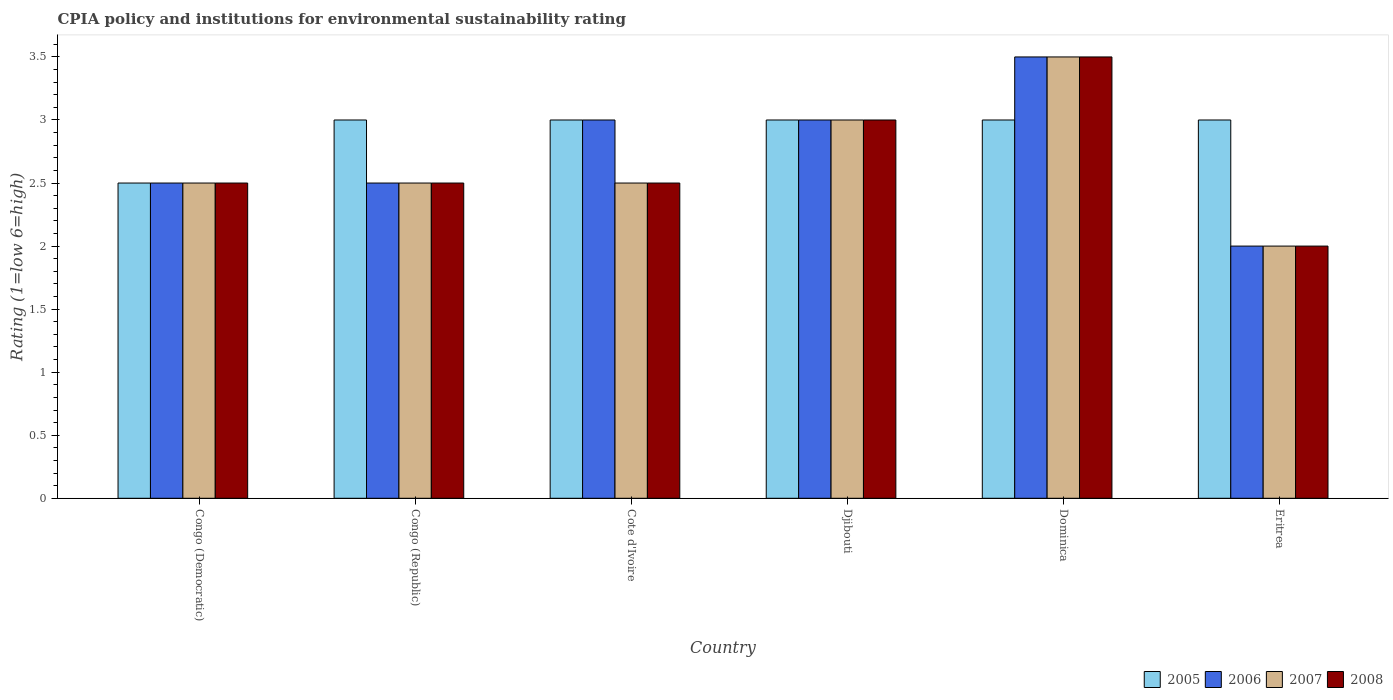Are the number of bars per tick equal to the number of legend labels?
Keep it short and to the point. Yes. How many bars are there on the 1st tick from the left?
Your answer should be very brief. 4. How many bars are there on the 5th tick from the right?
Your answer should be very brief. 4. What is the label of the 2nd group of bars from the left?
Make the answer very short. Congo (Republic). What is the CPIA rating in 2005 in Congo (Republic)?
Your answer should be compact. 3. Across all countries, what is the maximum CPIA rating in 2006?
Provide a short and direct response. 3.5. Across all countries, what is the minimum CPIA rating in 2005?
Your response must be concise. 2.5. In which country was the CPIA rating in 2008 maximum?
Your response must be concise. Dominica. In which country was the CPIA rating in 2006 minimum?
Your response must be concise. Eritrea. What is the total CPIA rating in 2005 in the graph?
Give a very brief answer. 17.5. What is the difference between the CPIA rating in 2007 in Congo (Democratic) and that in Djibouti?
Offer a very short reply. -0.5. What is the difference between the CPIA rating in 2006 in Djibouti and the CPIA rating in 2007 in Cote d'Ivoire?
Make the answer very short. 0.5. What is the average CPIA rating in 2007 per country?
Offer a terse response. 2.67. In how many countries, is the CPIA rating in 2007 greater than 0.9?
Give a very brief answer. 6. What is the ratio of the CPIA rating in 2005 in Djibouti to that in Eritrea?
Offer a terse response. 1. Is the CPIA rating in 2007 in Cote d'Ivoire less than that in Djibouti?
Your response must be concise. Yes. What is the difference between the highest and the second highest CPIA rating in 2008?
Give a very brief answer. 0.5. What is the difference between the highest and the lowest CPIA rating in 2007?
Your response must be concise. 1.5. In how many countries, is the CPIA rating in 2005 greater than the average CPIA rating in 2005 taken over all countries?
Your response must be concise. 5. What does the 4th bar from the left in Cote d'Ivoire represents?
Offer a very short reply. 2008. What does the 4th bar from the right in Congo (Democratic) represents?
Give a very brief answer. 2005. Is it the case that in every country, the sum of the CPIA rating in 2007 and CPIA rating in 2008 is greater than the CPIA rating in 2005?
Ensure brevity in your answer.  Yes. What is the difference between two consecutive major ticks on the Y-axis?
Provide a short and direct response. 0.5. Does the graph contain any zero values?
Provide a short and direct response. No. Does the graph contain grids?
Make the answer very short. No. Where does the legend appear in the graph?
Your answer should be very brief. Bottom right. How many legend labels are there?
Keep it short and to the point. 4. How are the legend labels stacked?
Offer a terse response. Horizontal. What is the title of the graph?
Give a very brief answer. CPIA policy and institutions for environmental sustainability rating. What is the label or title of the X-axis?
Keep it short and to the point. Country. What is the Rating (1=low 6=high) of 2008 in Congo (Democratic)?
Your answer should be compact. 2.5. What is the Rating (1=low 6=high) of 2006 in Congo (Republic)?
Keep it short and to the point. 2.5. What is the Rating (1=low 6=high) in 2007 in Congo (Republic)?
Provide a succinct answer. 2.5. What is the Rating (1=low 6=high) of 2008 in Congo (Republic)?
Offer a very short reply. 2.5. What is the Rating (1=low 6=high) of 2005 in Cote d'Ivoire?
Keep it short and to the point. 3. What is the Rating (1=low 6=high) in 2006 in Cote d'Ivoire?
Keep it short and to the point. 3. What is the Rating (1=low 6=high) of 2007 in Cote d'Ivoire?
Provide a short and direct response. 2.5. What is the Rating (1=low 6=high) of 2006 in Djibouti?
Provide a succinct answer. 3. What is the Rating (1=low 6=high) in 2007 in Djibouti?
Offer a very short reply. 3. What is the Rating (1=low 6=high) in 2008 in Djibouti?
Ensure brevity in your answer.  3. What is the Rating (1=low 6=high) in 2005 in Dominica?
Your response must be concise. 3. What is the Rating (1=low 6=high) of 2007 in Dominica?
Provide a succinct answer. 3.5. What is the Rating (1=low 6=high) of 2007 in Eritrea?
Your answer should be compact. 2. Across all countries, what is the maximum Rating (1=low 6=high) in 2006?
Make the answer very short. 3.5. Across all countries, what is the maximum Rating (1=low 6=high) in 2007?
Keep it short and to the point. 3.5. Across all countries, what is the minimum Rating (1=low 6=high) in 2005?
Provide a succinct answer. 2.5. Across all countries, what is the minimum Rating (1=low 6=high) in 2006?
Offer a very short reply. 2. Across all countries, what is the minimum Rating (1=low 6=high) of 2007?
Your response must be concise. 2. What is the total Rating (1=low 6=high) of 2006 in the graph?
Your response must be concise. 16.5. What is the total Rating (1=low 6=high) of 2007 in the graph?
Offer a terse response. 16. What is the difference between the Rating (1=low 6=high) in 2005 in Congo (Democratic) and that in Congo (Republic)?
Your answer should be very brief. -0.5. What is the difference between the Rating (1=low 6=high) of 2007 in Congo (Democratic) and that in Congo (Republic)?
Provide a succinct answer. 0. What is the difference between the Rating (1=low 6=high) of 2006 in Congo (Democratic) and that in Cote d'Ivoire?
Make the answer very short. -0.5. What is the difference between the Rating (1=low 6=high) of 2007 in Congo (Democratic) and that in Cote d'Ivoire?
Give a very brief answer. 0. What is the difference between the Rating (1=low 6=high) of 2008 in Congo (Democratic) and that in Cote d'Ivoire?
Offer a very short reply. 0. What is the difference between the Rating (1=low 6=high) of 2005 in Congo (Democratic) and that in Djibouti?
Your response must be concise. -0.5. What is the difference between the Rating (1=low 6=high) in 2008 in Congo (Democratic) and that in Djibouti?
Your answer should be very brief. -0.5. What is the difference between the Rating (1=low 6=high) in 2007 in Congo (Democratic) and that in Dominica?
Provide a succinct answer. -1. What is the difference between the Rating (1=low 6=high) in 2008 in Congo (Democratic) and that in Dominica?
Your answer should be compact. -1. What is the difference between the Rating (1=low 6=high) in 2005 in Congo (Republic) and that in Djibouti?
Your answer should be compact. 0. What is the difference between the Rating (1=low 6=high) in 2007 in Congo (Republic) and that in Djibouti?
Your answer should be compact. -0.5. What is the difference between the Rating (1=low 6=high) in 2005 in Congo (Republic) and that in Dominica?
Keep it short and to the point. 0. What is the difference between the Rating (1=low 6=high) of 2006 in Congo (Republic) and that in Dominica?
Offer a terse response. -1. What is the difference between the Rating (1=low 6=high) in 2007 in Congo (Republic) and that in Dominica?
Offer a terse response. -1. What is the difference between the Rating (1=low 6=high) in 2008 in Congo (Republic) and that in Dominica?
Offer a very short reply. -1. What is the difference between the Rating (1=low 6=high) of 2006 in Congo (Republic) and that in Eritrea?
Provide a succinct answer. 0.5. What is the difference between the Rating (1=low 6=high) in 2008 in Congo (Republic) and that in Eritrea?
Offer a terse response. 0.5. What is the difference between the Rating (1=low 6=high) of 2006 in Cote d'Ivoire and that in Djibouti?
Give a very brief answer. 0. What is the difference between the Rating (1=low 6=high) in 2007 in Cote d'Ivoire and that in Djibouti?
Your answer should be compact. -0.5. What is the difference between the Rating (1=low 6=high) in 2006 in Cote d'Ivoire and that in Dominica?
Your answer should be compact. -0.5. What is the difference between the Rating (1=low 6=high) in 2008 in Cote d'Ivoire and that in Dominica?
Provide a short and direct response. -1. What is the difference between the Rating (1=low 6=high) of 2005 in Cote d'Ivoire and that in Eritrea?
Keep it short and to the point. 0. What is the difference between the Rating (1=low 6=high) of 2007 in Cote d'Ivoire and that in Eritrea?
Ensure brevity in your answer.  0.5. What is the difference between the Rating (1=low 6=high) in 2005 in Djibouti and that in Dominica?
Offer a terse response. 0. What is the difference between the Rating (1=low 6=high) of 2006 in Djibouti and that in Dominica?
Your answer should be compact. -0.5. What is the difference between the Rating (1=low 6=high) in 2007 in Djibouti and that in Dominica?
Keep it short and to the point. -0.5. What is the difference between the Rating (1=low 6=high) in 2005 in Djibouti and that in Eritrea?
Your response must be concise. 0. What is the difference between the Rating (1=low 6=high) of 2006 in Djibouti and that in Eritrea?
Provide a succinct answer. 1. What is the difference between the Rating (1=low 6=high) in 2007 in Djibouti and that in Eritrea?
Your answer should be compact. 1. What is the difference between the Rating (1=low 6=high) of 2008 in Djibouti and that in Eritrea?
Your answer should be compact. 1. What is the difference between the Rating (1=low 6=high) in 2005 in Dominica and that in Eritrea?
Offer a terse response. 0. What is the difference between the Rating (1=low 6=high) of 2007 in Dominica and that in Eritrea?
Your answer should be very brief. 1.5. What is the difference between the Rating (1=low 6=high) in 2005 in Congo (Democratic) and the Rating (1=low 6=high) in 2007 in Congo (Republic)?
Give a very brief answer. 0. What is the difference between the Rating (1=low 6=high) in 2006 in Congo (Democratic) and the Rating (1=low 6=high) in 2007 in Congo (Republic)?
Offer a terse response. 0. What is the difference between the Rating (1=low 6=high) in 2006 in Congo (Democratic) and the Rating (1=low 6=high) in 2008 in Congo (Republic)?
Ensure brevity in your answer.  0. What is the difference between the Rating (1=low 6=high) in 2005 in Congo (Democratic) and the Rating (1=low 6=high) in 2006 in Cote d'Ivoire?
Your response must be concise. -0.5. What is the difference between the Rating (1=low 6=high) in 2005 in Congo (Democratic) and the Rating (1=low 6=high) in 2008 in Cote d'Ivoire?
Your response must be concise. 0. What is the difference between the Rating (1=low 6=high) in 2006 in Congo (Democratic) and the Rating (1=low 6=high) in 2007 in Cote d'Ivoire?
Keep it short and to the point. 0. What is the difference between the Rating (1=low 6=high) of 2005 in Congo (Democratic) and the Rating (1=low 6=high) of 2006 in Djibouti?
Provide a short and direct response. -0.5. What is the difference between the Rating (1=low 6=high) in 2005 in Congo (Democratic) and the Rating (1=low 6=high) in 2007 in Djibouti?
Ensure brevity in your answer.  -0.5. What is the difference between the Rating (1=low 6=high) of 2006 in Congo (Democratic) and the Rating (1=low 6=high) of 2007 in Djibouti?
Provide a succinct answer. -0.5. What is the difference between the Rating (1=low 6=high) in 2005 in Congo (Democratic) and the Rating (1=low 6=high) in 2008 in Dominica?
Provide a succinct answer. -1. What is the difference between the Rating (1=low 6=high) of 2006 in Congo (Democratic) and the Rating (1=low 6=high) of 2007 in Dominica?
Offer a terse response. -1. What is the difference between the Rating (1=low 6=high) in 2007 in Congo (Democratic) and the Rating (1=low 6=high) in 2008 in Dominica?
Give a very brief answer. -1. What is the difference between the Rating (1=low 6=high) in 2005 in Congo (Democratic) and the Rating (1=low 6=high) in 2006 in Eritrea?
Provide a succinct answer. 0.5. What is the difference between the Rating (1=low 6=high) in 2006 in Congo (Democratic) and the Rating (1=low 6=high) in 2007 in Eritrea?
Provide a short and direct response. 0.5. What is the difference between the Rating (1=low 6=high) in 2006 in Congo (Democratic) and the Rating (1=low 6=high) in 2008 in Eritrea?
Give a very brief answer. 0.5. What is the difference between the Rating (1=low 6=high) of 2007 in Congo (Democratic) and the Rating (1=low 6=high) of 2008 in Eritrea?
Ensure brevity in your answer.  0.5. What is the difference between the Rating (1=low 6=high) of 2005 in Congo (Republic) and the Rating (1=low 6=high) of 2006 in Cote d'Ivoire?
Your answer should be very brief. 0. What is the difference between the Rating (1=low 6=high) of 2005 in Congo (Republic) and the Rating (1=low 6=high) of 2007 in Cote d'Ivoire?
Your answer should be compact. 0.5. What is the difference between the Rating (1=low 6=high) of 2005 in Congo (Republic) and the Rating (1=low 6=high) of 2008 in Cote d'Ivoire?
Offer a very short reply. 0.5. What is the difference between the Rating (1=low 6=high) in 2006 in Congo (Republic) and the Rating (1=low 6=high) in 2007 in Cote d'Ivoire?
Your answer should be compact. 0. What is the difference between the Rating (1=low 6=high) in 2006 in Congo (Republic) and the Rating (1=low 6=high) in 2008 in Cote d'Ivoire?
Your answer should be compact. 0. What is the difference between the Rating (1=low 6=high) in 2007 in Congo (Republic) and the Rating (1=low 6=high) in 2008 in Cote d'Ivoire?
Keep it short and to the point. 0. What is the difference between the Rating (1=low 6=high) of 2005 in Congo (Republic) and the Rating (1=low 6=high) of 2006 in Djibouti?
Keep it short and to the point. 0. What is the difference between the Rating (1=low 6=high) in 2005 in Congo (Republic) and the Rating (1=low 6=high) in 2008 in Djibouti?
Offer a terse response. 0. What is the difference between the Rating (1=low 6=high) of 2006 in Congo (Republic) and the Rating (1=low 6=high) of 2008 in Djibouti?
Offer a terse response. -0.5. What is the difference between the Rating (1=low 6=high) in 2005 in Congo (Republic) and the Rating (1=low 6=high) in 2006 in Dominica?
Offer a terse response. -0.5. What is the difference between the Rating (1=low 6=high) of 2005 in Congo (Republic) and the Rating (1=low 6=high) of 2007 in Dominica?
Ensure brevity in your answer.  -0.5. What is the difference between the Rating (1=low 6=high) of 2005 in Congo (Republic) and the Rating (1=low 6=high) of 2008 in Dominica?
Offer a terse response. -0.5. What is the difference between the Rating (1=low 6=high) in 2006 in Congo (Republic) and the Rating (1=low 6=high) in 2007 in Dominica?
Offer a terse response. -1. What is the difference between the Rating (1=low 6=high) of 2005 in Congo (Republic) and the Rating (1=low 6=high) of 2006 in Eritrea?
Offer a terse response. 1. What is the difference between the Rating (1=low 6=high) of 2005 in Congo (Republic) and the Rating (1=low 6=high) of 2007 in Eritrea?
Ensure brevity in your answer.  1. What is the difference between the Rating (1=low 6=high) in 2005 in Congo (Republic) and the Rating (1=low 6=high) in 2008 in Eritrea?
Provide a succinct answer. 1. What is the difference between the Rating (1=low 6=high) in 2006 in Congo (Republic) and the Rating (1=low 6=high) in 2007 in Eritrea?
Provide a succinct answer. 0.5. What is the difference between the Rating (1=low 6=high) in 2006 in Congo (Republic) and the Rating (1=low 6=high) in 2008 in Eritrea?
Make the answer very short. 0.5. What is the difference between the Rating (1=low 6=high) in 2005 in Cote d'Ivoire and the Rating (1=low 6=high) in 2006 in Djibouti?
Make the answer very short. 0. What is the difference between the Rating (1=low 6=high) of 2005 in Cote d'Ivoire and the Rating (1=low 6=high) of 2008 in Djibouti?
Your response must be concise. 0. What is the difference between the Rating (1=low 6=high) of 2006 in Cote d'Ivoire and the Rating (1=low 6=high) of 2007 in Djibouti?
Offer a very short reply. 0. What is the difference between the Rating (1=low 6=high) of 2006 in Cote d'Ivoire and the Rating (1=low 6=high) of 2008 in Djibouti?
Your answer should be very brief. 0. What is the difference between the Rating (1=low 6=high) of 2005 in Cote d'Ivoire and the Rating (1=low 6=high) of 2006 in Dominica?
Your answer should be compact. -0.5. What is the difference between the Rating (1=low 6=high) in 2005 in Cote d'Ivoire and the Rating (1=low 6=high) in 2008 in Dominica?
Ensure brevity in your answer.  -0.5. What is the difference between the Rating (1=low 6=high) in 2005 in Cote d'Ivoire and the Rating (1=low 6=high) in 2006 in Eritrea?
Offer a terse response. 1. What is the difference between the Rating (1=low 6=high) of 2006 in Cote d'Ivoire and the Rating (1=low 6=high) of 2008 in Eritrea?
Offer a terse response. 1. What is the difference between the Rating (1=low 6=high) in 2005 in Djibouti and the Rating (1=low 6=high) in 2007 in Eritrea?
Offer a terse response. 1. What is the difference between the Rating (1=low 6=high) in 2006 in Djibouti and the Rating (1=low 6=high) in 2007 in Eritrea?
Provide a succinct answer. 1. What is the difference between the Rating (1=low 6=high) of 2005 in Dominica and the Rating (1=low 6=high) of 2007 in Eritrea?
Offer a terse response. 1. What is the difference between the Rating (1=low 6=high) of 2005 in Dominica and the Rating (1=low 6=high) of 2008 in Eritrea?
Your response must be concise. 1. What is the difference between the Rating (1=low 6=high) of 2006 in Dominica and the Rating (1=low 6=high) of 2007 in Eritrea?
Your answer should be compact. 1.5. What is the difference between the Rating (1=low 6=high) in 2007 in Dominica and the Rating (1=low 6=high) in 2008 in Eritrea?
Give a very brief answer. 1.5. What is the average Rating (1=low 6=high) of 2005 per country?
Give a very brief answer. 2.92. What is the average Rating (1=low 6=high) in 2006 per country?
Make the answer very short. 2.75. What is the average Rating (1=low 6=high) of 2007 per country?
Your response must be concise. 2.67. What is the average Rating (1=low 6=high) of 2008 per country?
Give a very brief answer. 2.67. What is the difference between the Rating (1=low 6=high) in 2005 and Rating (1=low 6=high) in 2006 in Congo (Democratic)?
Give a very brief answer. 0. What is the difference between the Rating (1=low 6=high) in 2005 and Rating (1=low 6=high) in 2007 in Congo (Democratic)?
Offer a very short reply. 0. What is the difference between the Rating (1=low 6=high) of 2005 and Rating (1=low 6=high) of 2008 in Congo (Democratic)?
Your response must be concise. 0. What is the difference between the Rating (1=low 6=high) in 2006 and Rating (1=low 6=high) in 2007 in Congo (Democratic)?
Offer a terse response. 0. What is the difference between the Rating (1=low 6=high) in 2007 and Rating (1=low 6=high) in 2008 in Congo (Democratic)?
Make the answer very short. 0. What is the difference between the Rating (1=low 6=high) of 2005 and Rating (1=low 6=high) of 2008 in Congo (Republic)?
Give a very brief answer. 0.5. What is the difference between the Rating (1=low 6=high) in 2006 and Rating (1=low 6=high) in 2007 in Congo (Republic)?
Keep it short and to the point. 0. What is the difference between the Rating (1=low 6=high) of 2007 and Rating (1=low 6=high) of 2008 in Congo (Republic)?
Give a very brief answer. 0. What is the difference between the Rating (1=low 6=high) of 2005 and Rating (1=low 6=high) of 2008 in Cote d'Ivoire?
Keep it short and to the point. 0.5. What is the difference between the Rating (1=low 6=high) of 2006 and Rating (1=low 6=high) of 2008 in Cote d'Ivoire?
Your answer should be very brief. 0.5. What is the difference between the Rating (1=low 6=high) of 2005 and Rating (1=low 6=high) of 2006 in Djibouti?
Provide a short and direct response. 0. What is the difference between the Rating (1=low 6=high) of 2005 and Rating (1=low 6=high) of 2007 in Djibouti?
Give a very brief answer. 0. What is the difference between the Rating (1=low 6=high) of 2006 and Rating (1=low 6=high) of 2007 in Djibouti?
Your answer should be very brief. 0. What is the difference between the Rating (1=low 6=high) of 2006 and Rating (1=low 6=high) of 2008 in Djibouti?
Ensure brevity in your answer.  0. What is the difference between the Rating (1=low 6=high) of 2005 and Rating (1=low 6=high) of 2006 in Dominica?
Keep it short and to the point. -0.5. What is the difference between the Rating (1=low 6=high) in 2005 and Rating (1=low 6=high) in 2008 in Dominica?
Provide a short and direct response. -0.5. What is the difference between the Rating (1=low 6=high) of 2006 and Rating (1=low 6=high) of 2008 in Dominica?
Provide a succinct answer. 0. What is the difference between the Rating (1=low 6=high) of 2005 and Rating (1=low 6=high) of 2007 in Eritrea?
Give a very brief answer. 1. What is the difference between the Rating (1=low 6=high) of 2006 and Rating (1=low 6=high) of 2007 in Eritrea?
Keep it short and to the point. 0. What is the difference between the Rating (1=low 6=high) in 2006 and Rating (1=low 6=high) in 2008 in Eritrea?
Your answer should be compact. 0. What is the difference between the Rating (1=low 6=high) of 2007 and Rating (1=low 6=high) of 2008 in Eritrea?
Provide a short and direct response. 0. What is the ratio of the Rating (1=low 6=high) of 2005 in Congo (Democratic) to that in Congo (Republic)?
Offer a terse response. 0.83. What is the ratio of the Rating (1=low 6=high) of 2006 in Congo (Democratic) to that in Congo (Republic)?
Offer a very short reply. 1. What is the ratio of the Rating (1=low 6=high) of 2007 in Congo (Democratic) to that in Congo (Republic)?
Make the answer very short. 1. What is the ratio of the Rating (1=low 6=high) of 2008 in Congo (Democratic) to that in Congo (Republic)?
Keep it short and to the point. 1. What is the ratio of the Rating (1=low 6=high) in 2008 in Congo (Democratic) to that in Cote d'Ivoire?
Keep it short and to the point. 1. What is the ratio of the Rating (1=low 6=high) in 2006 in Congo (Democratic) to that in Djibouti?
Offer a very short reply. 0.83. What is the ratio of the Rating (1=low 6=high) of 2008 in Congo (Democratic) to that in Djibouti?
Provide a succinct answer. 0.83. What is the ratio of the Rating (1=low 6=high) of 2005 in Congo (Democratic) to that in Dominica?
Provide a succinct answer. 0.83. What is the ratio of the Rating (1=low 6=high) of 2005 in Congo (Republic) to that in Cote d'Ivoire?
Your response must be concise. 1. What is the ratio of the Rating (1=low 6=high) in 2008 in Congo (Republic) to that in Cote d'Ivoire?
Ensure brevity in your answer.  1. What is the ratio of the Rating (1=low 6=high) in 2008 in Congo (Republic) to that in Djibouti?
Your answer should be compact. 0.83. What is the ratio of the Rating (1=low 6=high) of 2005 in Congo (Republic) to that in Dominica?
Give a very brief answer. 1. What is the ratio of the Rating (1=low 6=high) of 2007 in Congo (Republic) to that in Dominica?
Provide a short and direct response. 0.71. What is the ratio of the Rating (1=low 6=high) of 2008 in Congo (Republic) to that in Dominica?
Offer a very short reply. 0.71. What is the ratio of the Rating (1=low 6=high) of 2007 in Congo (Republic) to that in Eritrea?
Provide a short and direct response. 1.25. What is the ratio of the Rating (1=low 6=high) of 2008 in Congo (Republic) to that in Eritrea?
Your answer should be compact. 1.25. What is the ratio of the Rating (1=low 6=high) in 2005 in Cote d'Ivoire to that in Djibouti?
Offer a terse response. 1. What is the ratio of the Rating (1=low 6=high) of 2006 in Cote d'Ivoire to that in Djibouti?
Make the answer very short. 1. What is the ratio of the Rating (1=low 6=high) in 2005 in Cote d'Ivoire to that in Dominica?
Offer a very short reply. 1. What is the ratio of the Rating (1=low 6=high) of 2007 in Cote d'Ivoire to that in Dominica?
Your answer should be compact. 0.71. What is the ratio of the Rating (1=low 6=high) in 2008 in Cote d'Ivoire to that in Eritrea?
Give a very brief answer. 1.25. What is the ratio of the Rating (1=low 6=high) in 2005 in Djibouti to that in Dominica?
Your response must be concise. 1. What is the ratio of the Rating (1=low 6=high) of 2007 in Djibouti to that in Dominica?
Make the answer very short. 0.86. What is the ratio of the Rating (1=low 6=high) of 2008 in Djibouti to that in Dominica?
Your answer should be very brief. 0.86. What is the ratio of the Rating (1=low 6=high) of 2008 in Djibouti to that in Eritrea?
Your response must be concise. 1.5. What is the ratio of the Rating (1=low 6=high) in 2005 in Dominica to that in Eritrea?
Provide a succinct answer. 1. What is the ratio of the Rating (1=low 6=high) of 2007 in Dominica to that in Eritrea?
Provide a short and direct response. 1.75. What is the difference between the highest and the second highest Rating (1=low 6=high) of 2006?
Offer a very short reply. 0.5. What is the difference between the highest and the second highest Rating (1=low 6=high) in 2007?
Give a very brief answer. 0.5. What is the difference between the highest and the lowest Rating (1=low 6=high) in 2005?
Your response must be concise. 0.5. What is the difference between the highest and the lowest Rating (1=low 6=high) in 2006?
Provide a short and direct response. 1.5. What is the difference between the highest and the lowest Rating (1=low 6=high) in 2007?
Your answer should be very brief. 1.5. 